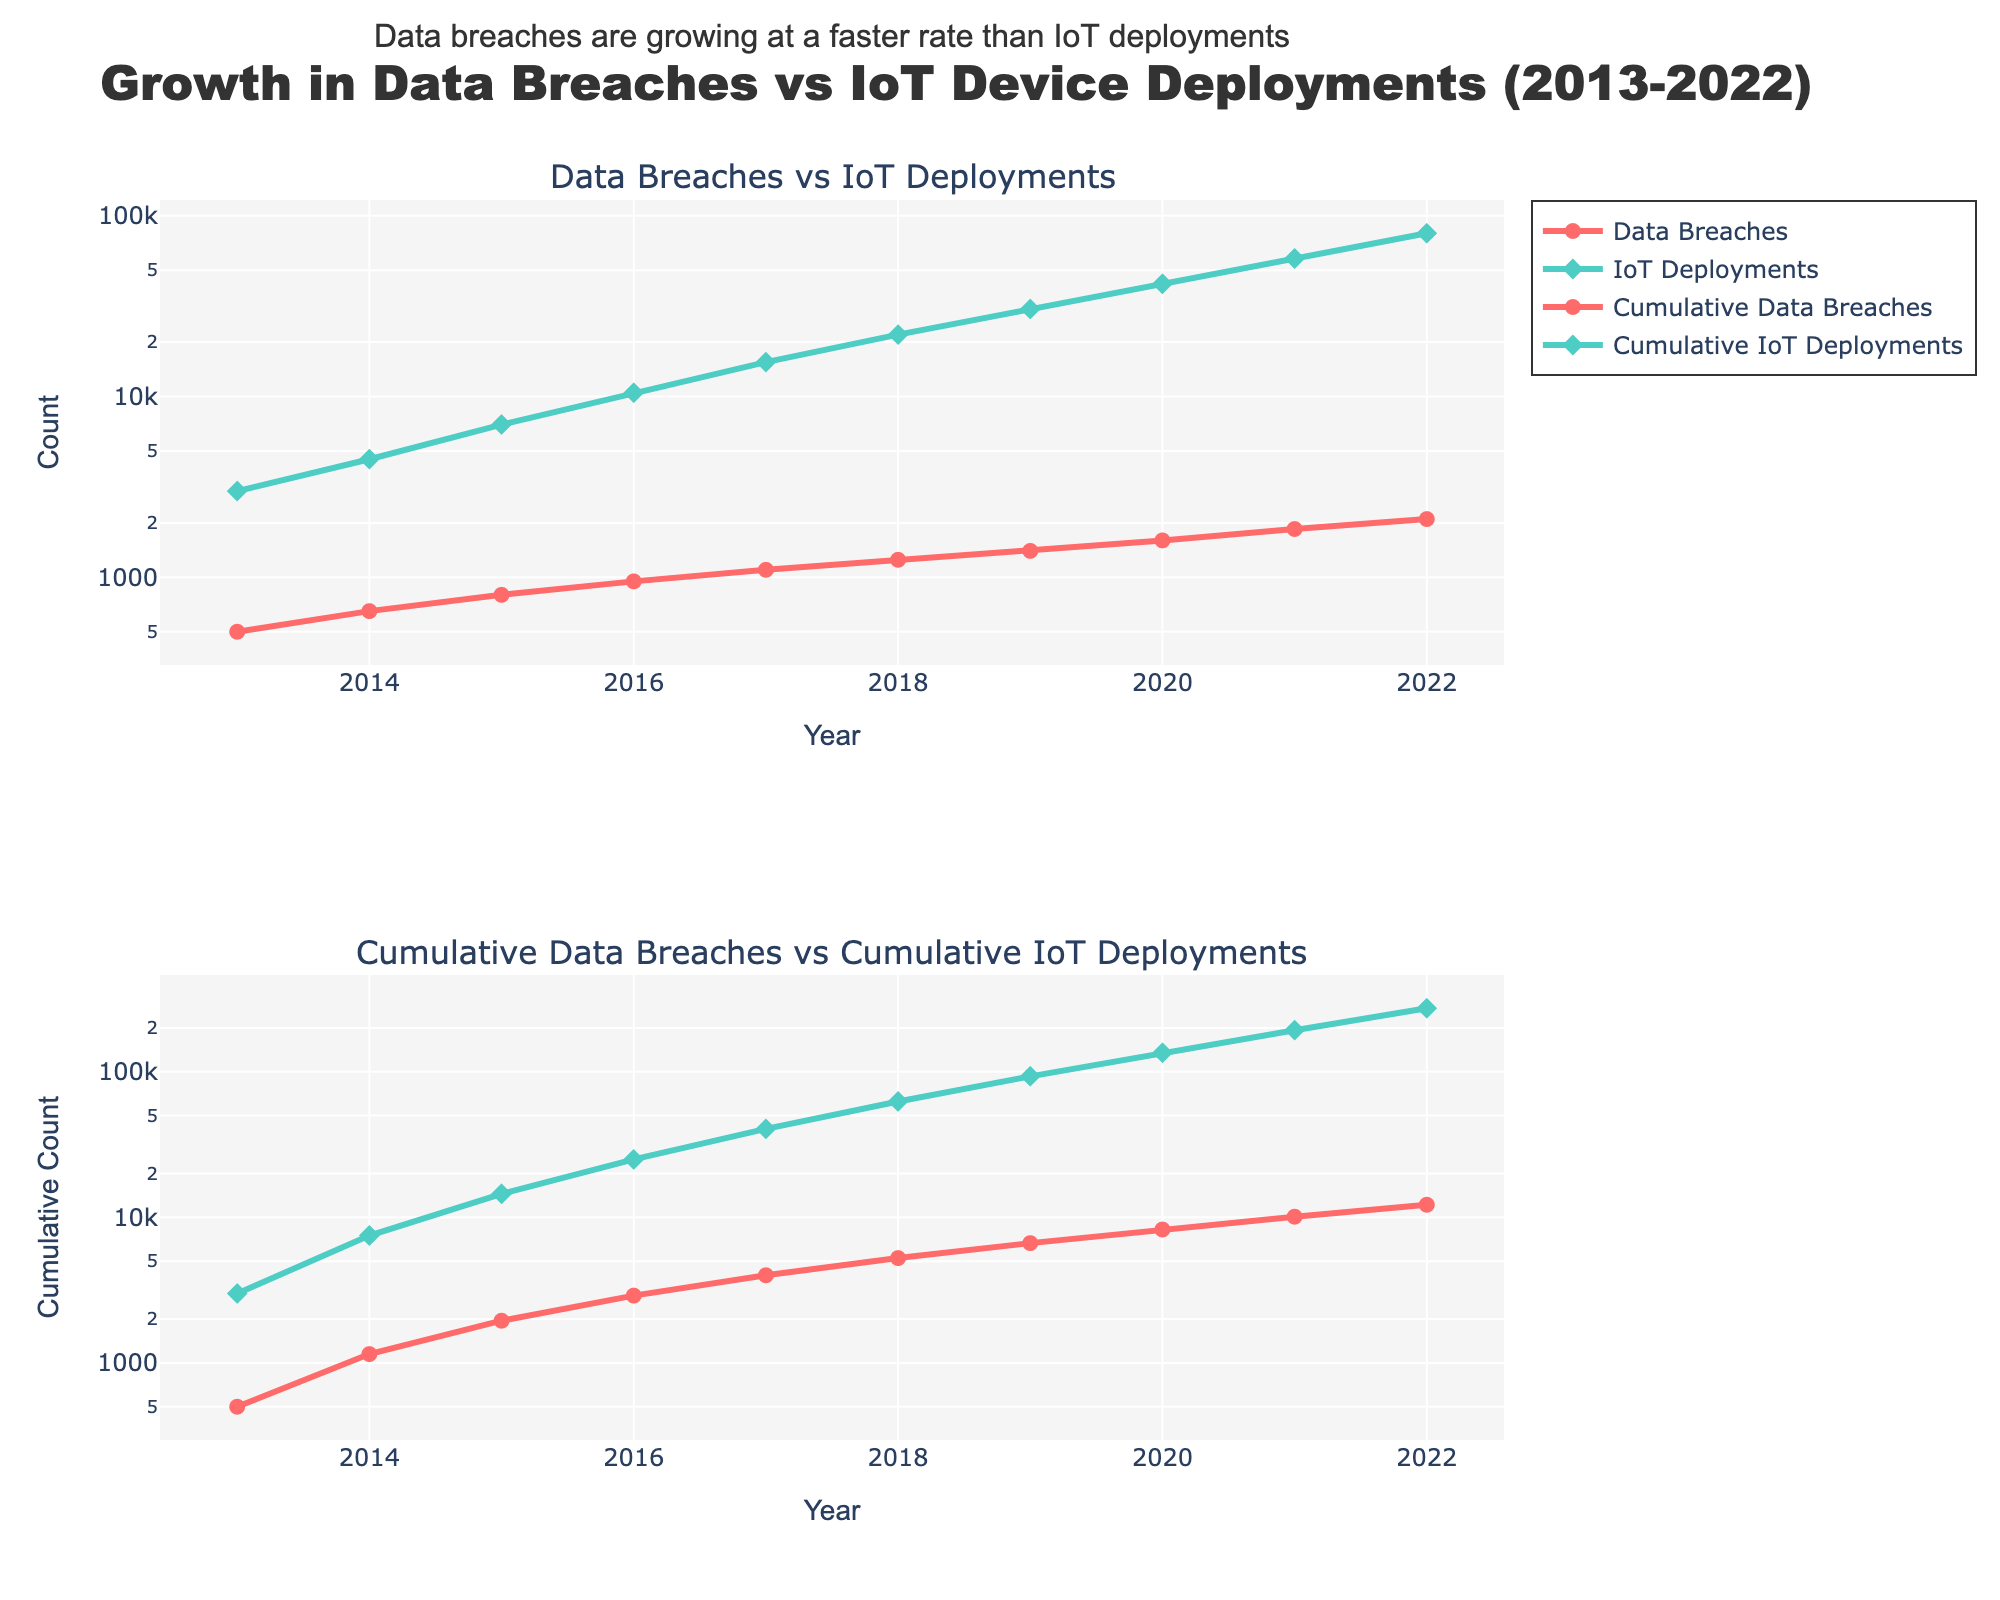How does the rate of growth in data breaches compare to the rate of growth in IoT deployments over the decade? To compare the rates, examine the slopes of the lines in both subplots. In the first subplot, the slope of the Data Breaches line (red) is steeper than the IoT Deployments line (green), indicating that data breaches are growing at a faster rate. This is further supported by the annotation provided.
Answer: Data breaches are growing faster What is the title of the figure? The title is displayed at the top center of the figure.
Answer: Growth in Data Breaches vs IoT Device Deployments (2013-2022) Looking at the log scale subplots, what was the trend in cumulative IoT deployments? Cumulative IoT Deployments (green line) have shown a consistently upward trend each year, indicating continuous growth. This can be confirmed by observing the steadily increasing line in the second subplot.
Answer: Continuous upward trend In which year did the cumulative data breaches surpass 10,000? To find when cumulative data breaches surpassed 10,000, check the second subplot's red line. It surpassed the 10,000 mark in 2021.
Answer: 2021 Which subplot shows the cumulative data count, and which one shows the annual count? The first subplot displays the annual counts for Data Breaches and IoT Deployments, while the second subplot shows the cumulative counts. The second subplot titles include "Cumulative" indicating cumulative data.
Answer: First: Annual, Second: Cumulative Comparing the years 2018 and 2022, which had a higher increase in IoT deployments? Calculate the difference between IoT deployments for these two years: 2022 had 80,000, and 2018 had 22,000. The difference is 80,000 - 22,000 = 58,000.
Answer: 2022 What visualization technique is used in both subplots to handle the wide range of values? Both subplots use a log scale on the y-axis to handle the wide range of values, allowing us to observe trends despite the large differences in magnitude.
Answer: Log scale How do the cumulative data breaches in 2020 compare to those in 2017? To compare, look at the second subplot. In 2020, cumulative data breaches were over 8,250, while in 2017, they were 4,000.
Answer: 2020 had more What do the symbols on the lines in the plots represent? The symbols (circles for data breaches and diamonds for IoT deployments) represent data points in both subplots, marking the values for each year.
Answer: Data points for each year 